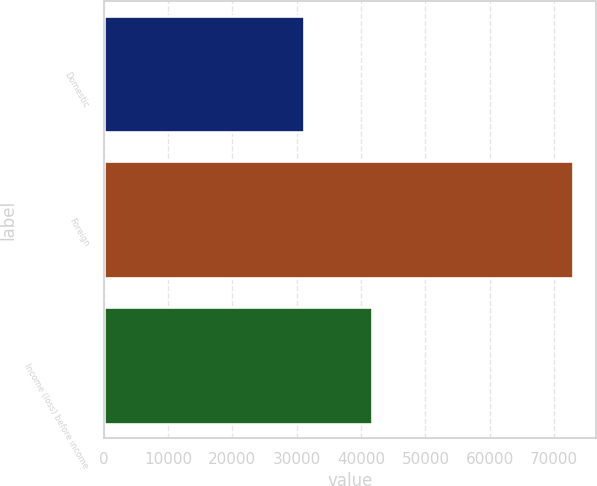Convert chart to OTSL. <chart><loc_0><loc_0><loc_500><loc_500><bar_chart><fcel>Domestic<fcel>Foreign<fcel>Income (loss) before income<nl><fcel>31122<fcel>72842<fcel>41720<nl></chart> 